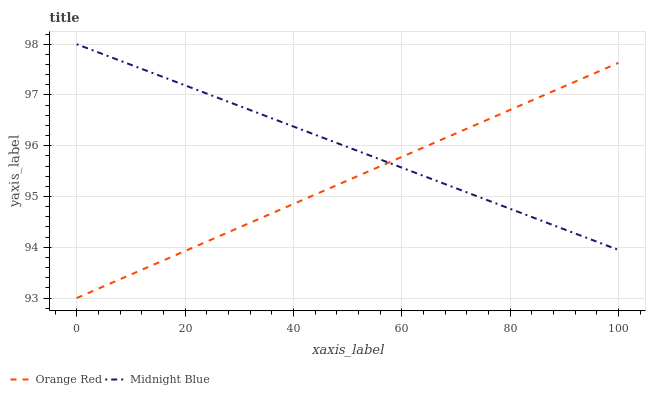Does Orange Red have the minimum area under the curve?
Answer yes or no. Yes. Does Midnight Blue have the maximum area under the curve?
Answer yes or no. Yes. Does Midnight Blue have the minimum area under the curve?
Answer yes or no. No. Is Midnight Blue the smoothest?
Answer yes or no. Yes. Is Orange Red the roughest?
Answer yes or no. Yes. Is Midnight Blue the roughest?
Answer yes or no. No. Does Orange Red have the lowest value?
Answer yes or no. Yes. Does Midnight Blue have the lowest value?
Answer yes or no. No. Does Midnight Blue have the highest value?
Answer yes or no. Yes. Does Orange Red intersect Midnight Blue?
Answer yes or no. Yes. Is Orange Red less than Midnight Blue?
Answer yes or no. No. Is Orange Red greater than Midnight Blue?
Answer yes or no. No. 